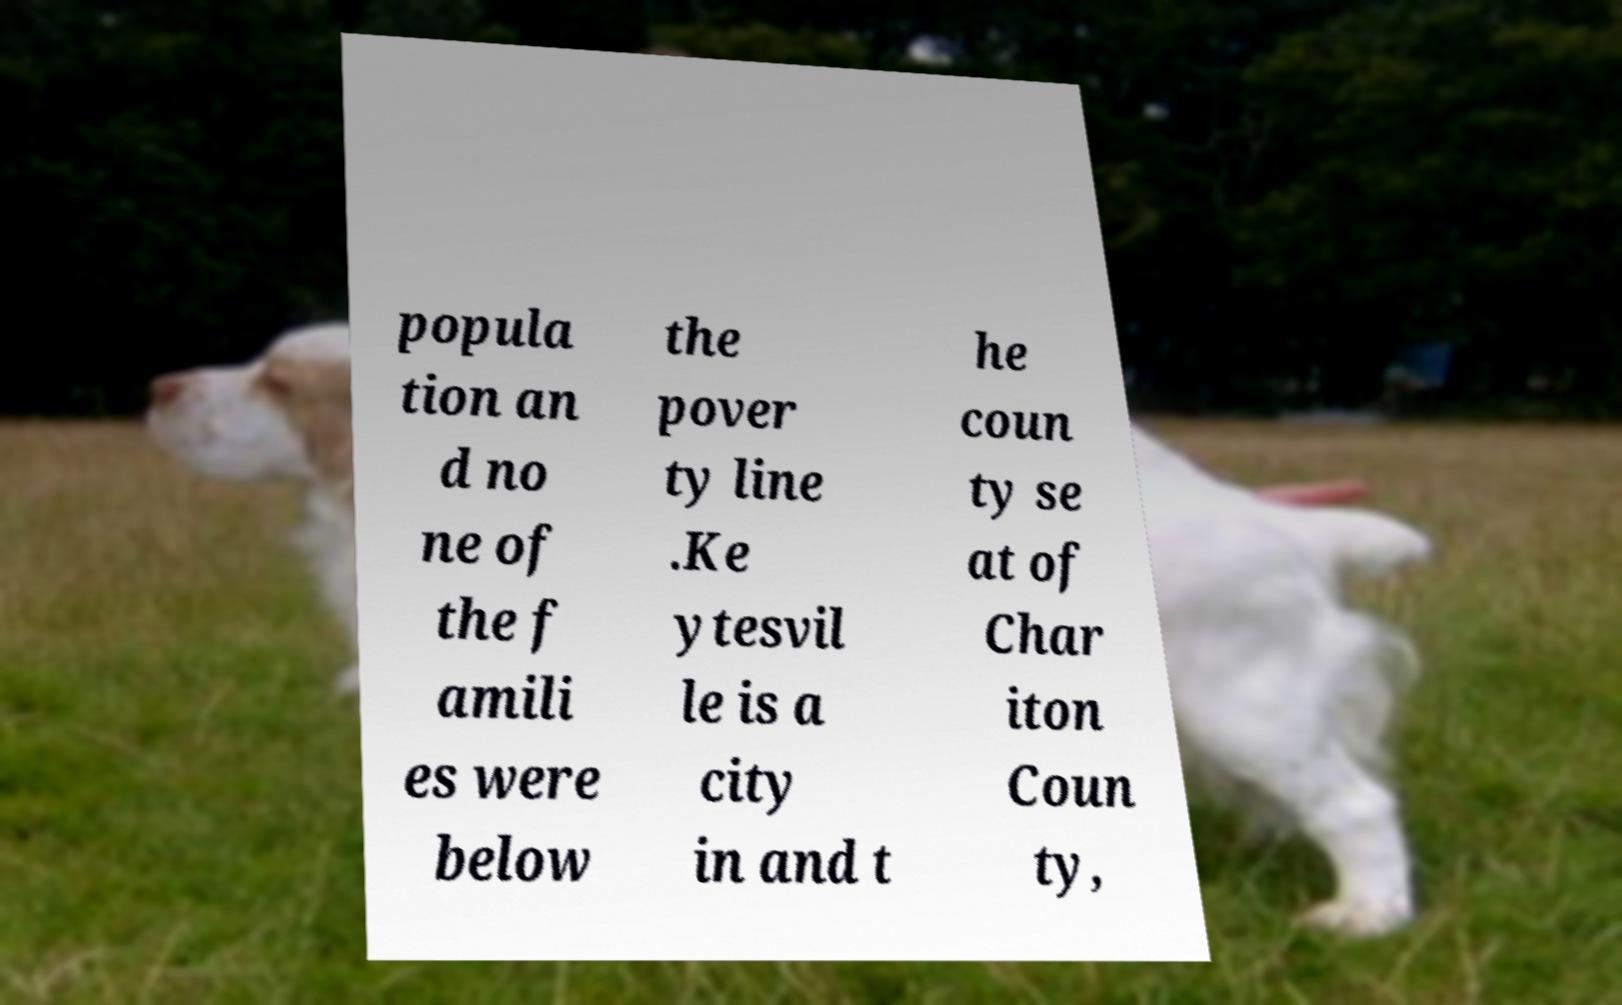There's text embedded in this image that I need extracted. Can you transcribe it verbatim? popula tion an d no ne of the f amili es were below the pover ty line .Ke ytesvil le is a city in and t he coun ty se at of Char iton Coun ty, 